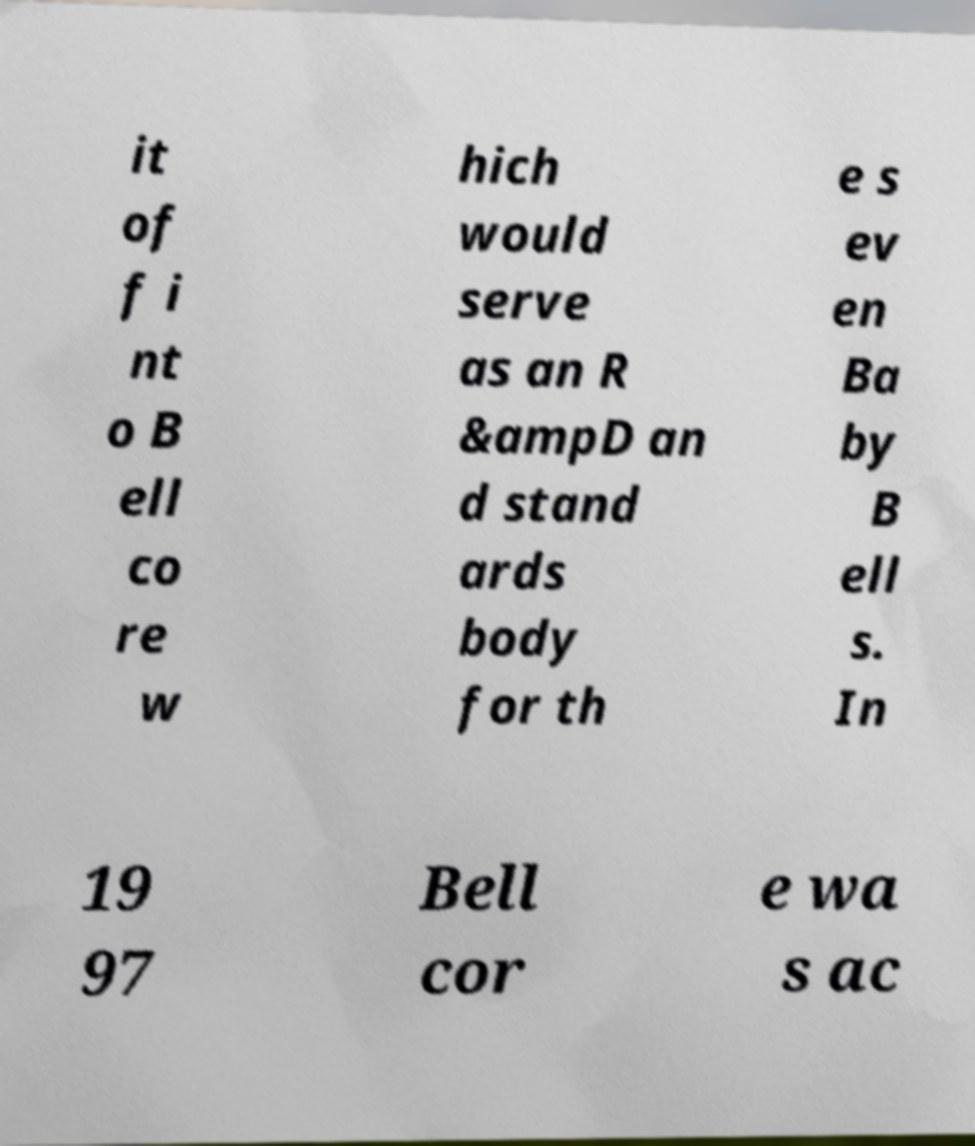Could you extract and type out the text from this image? it of f i nt o B ell co re w hich would serve as an R &ampD an d stand ards body for th e s ev en Ba by B ell s. In 19 97 Bell cor e wa s ac 